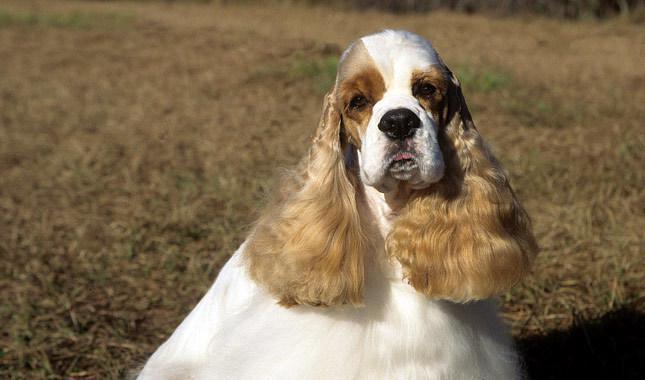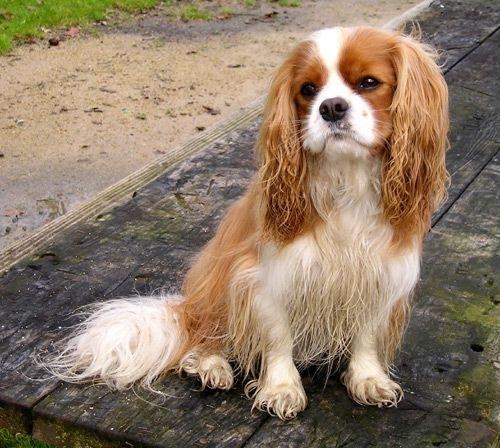The first image is the image on the left, the second image is the image on the right. Analyze the images presented: Is the assertion "In one of the images the dog is lying down." valid? Answer yes or no. No. 